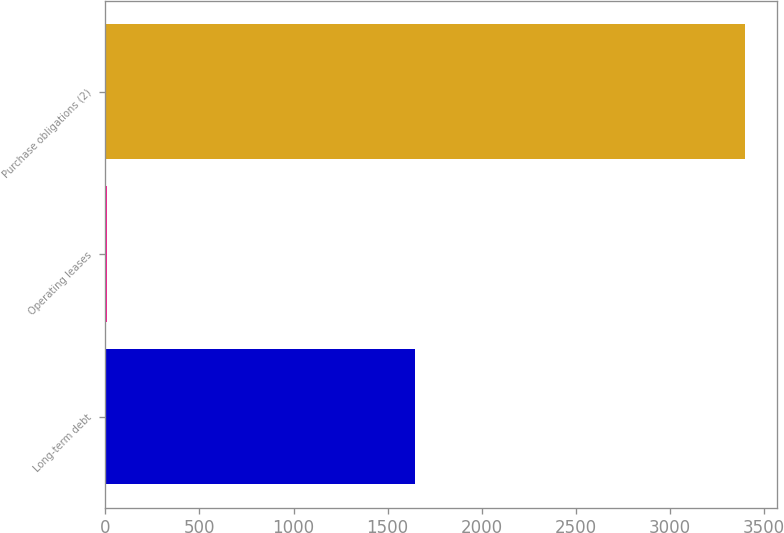<chart> <loc_0><loc_0><loc_500><loc_500><bar_chart><fcel>Long-term debt<fcel>Operating leases<fcel>Purchase obligations (2)<nl><fcel>1648<fcel>8<fcel>3402<nl></chart> 